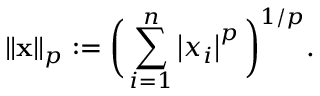<formula> <loc_0><loc_0><loc_500><loc_500>\left \| x \right \| _ { p } \colon = { \left ( } \sum _ { i = 1 } ^ { n } \left | x _ { i } \right | ^ { p } { \right ) } ^ { 1 / p } .</formula> 